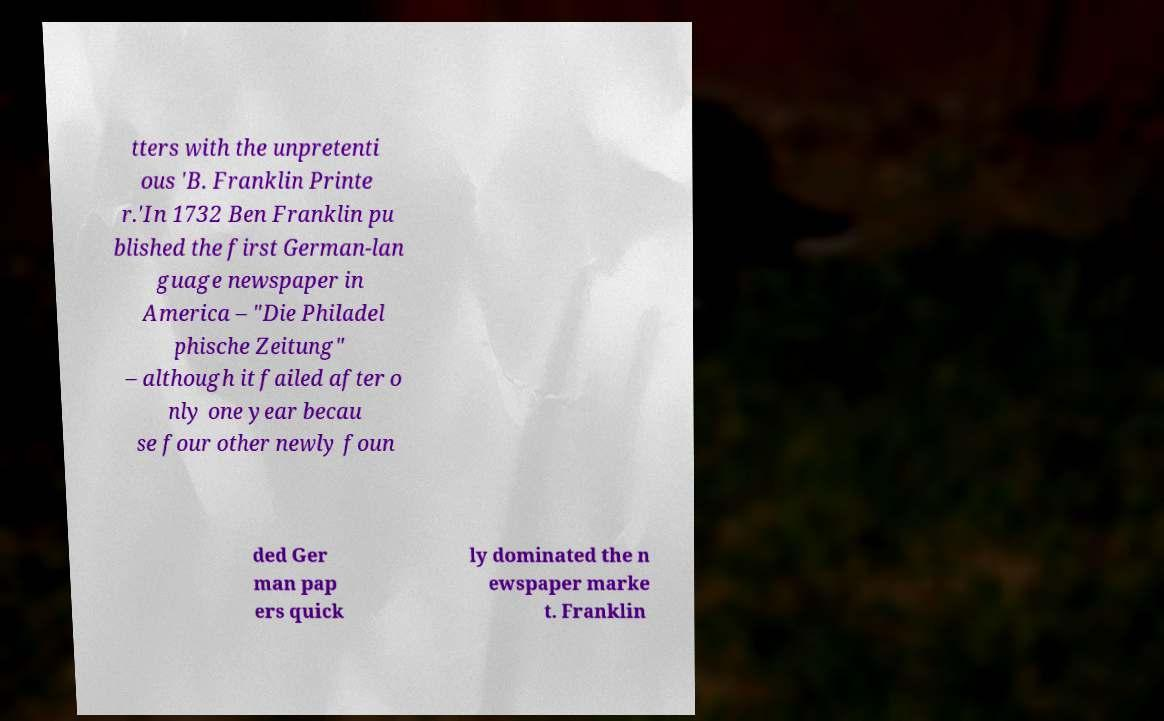I need the written content from this picture converted into text. Can you do that? tters with the unpretenti ous 'B. Franklin Printe r.'In 1732 Ben Franklin pu blished the first German-lan guage newspaper in America – "Die Philadel phische Zeitung" – although it failed after o nly one year becau se four other newly foun ded Ger man pap ers quick ly dominated the n ewspaper marke t. Franklin 